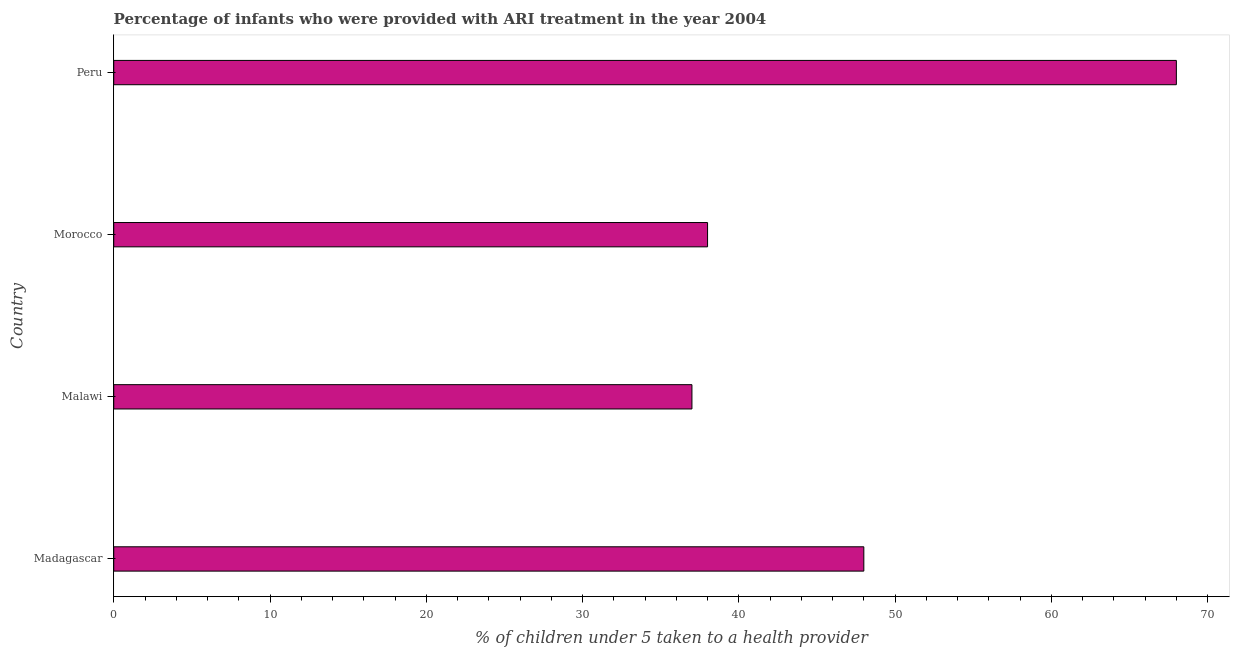Does the graph contain any zero values?
Your response must be concise. No. What is the title of the graph?
Your answer should be very brief. Percentage of infants who were provided with ARI treatment in the year 2004. What is the label or title of the X-axis?
Your answer should be very brief. % of children under 5 taken to a health provider. What is the label or title of the Y-axis?
Provide a succinct answer. Country. In which country was the percentage of children who were provided with ari treatment minimum?
Your answer should be compact. Malawi. What is the sum of the percentage of children who were provided with ari treatment?
Provide a short and direct response. 191. What is the difference between the percentage of children who were provided with ari treatment in Madagascar and Peru?
Ensure brevity in your answer.  -20. What is the average percentage of children who were provided with ari treatment per country?
Provide a short and direct response. 47.75. What is the median percentage of children who were provided with ari treatment?
Give a very brief answer. 43. What is the ratio of the percentage of children who were provided with ari treatment in Morocco to that in Peru?
Keep it short and to the point. 0.56. Is the difference between the percentage of children who were provided with ari treatment in Madagascar and Peru greater than the difference between any two countries?
Your answer should be very brief. No. In how many countries, is the percentage of children who were provided with ari treatment greater than the average percentage of children who were provided with ari treatment taken over all countries?
Your response must be concise. 2. Are all the bars in the graph horizontal?
Ensure brevity in your answer.  Yes. Are the values on the major ticks of X-axis written in scientific E-notation?
Provide a short and direct response. No. What is the % of children under 5 taken to a health provider of Madagascar?
Ensure brevity in your answer.  48. What is the % of children under 5 taken to a health provider of Morocco?
Ensure brevity in your answer.  38. What is the % of children under 5 taken to a health provider of Peru?
Make the answer very short. 68. What is the difference between the % of children under 5 taken to a health provider in Madagascar and Morocco?
Provide a short and direct response. 10. What is the difference between the % of children under 5 taken to a health provider in Malawi and Peru?
Provide a short and direct response. -31. What is the difference between the % of children under 5 taken to a health provider in Morocco and Peru?
Ensure brevity in your answer.  -30. What is the ratio of the % of children under 5 taken to a health provider in Madagascar to that in Malawi?
Offer a terse response. 1.3. What is the ratio of the % of children under 5 taken to a health provider in Madagascar to that in Morocco?
Provide a short and direct response. 1.26. What is the ratio of the % of children under 5 taken to a health provider in Madagascar to that in Peru?
Provide a short and direct response. 0.71. What is the ratio of the % of children under 5 taken to a health provider in Malawi to that in Morocco?
Offer a terse response. 0.97. What is the ratio of the % of children under 5 taken to a health provider in Malawi to that in Peru?
Make the answer very short. 0.54. What is the ratio of the % of children under 5 taken to a health provider in Morocco to that in Peru?
Your answer should be very brief. 0.56. 